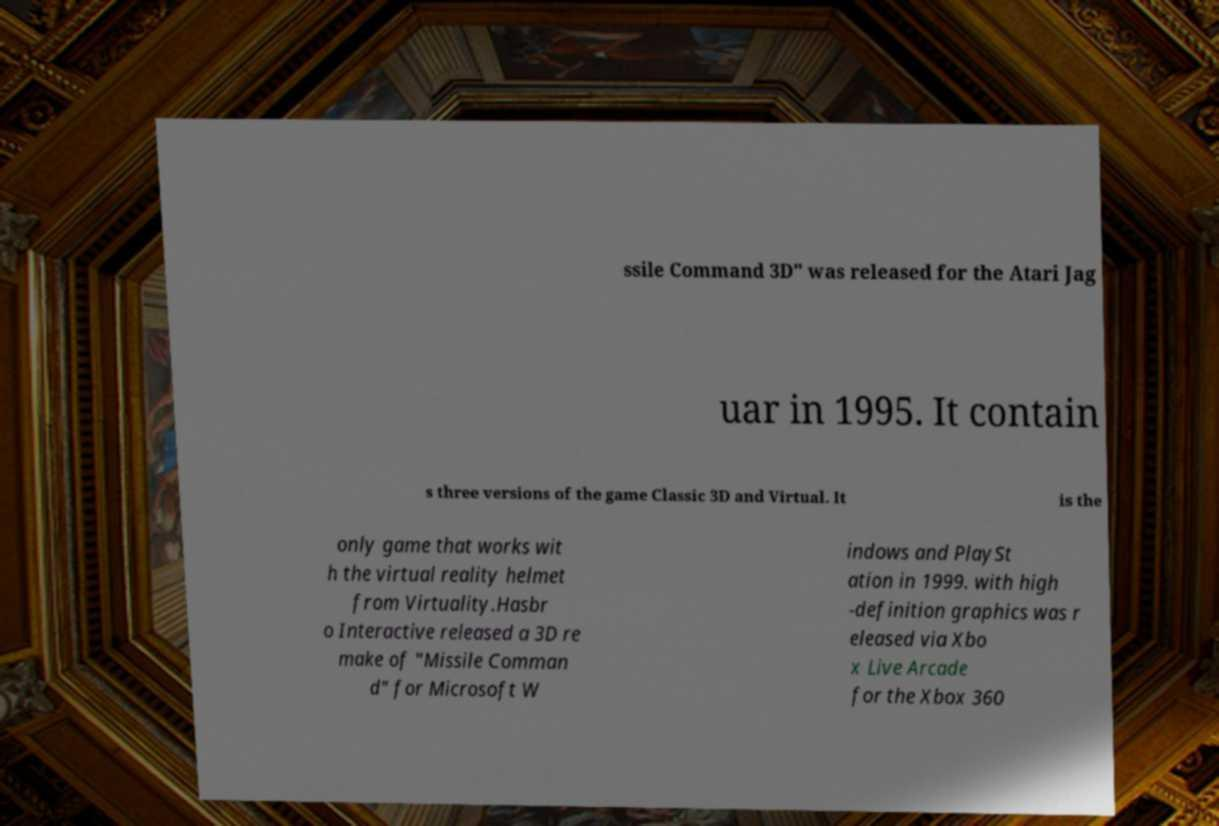Please read and relay the text visible in this image. What does it say? ssile Command 3D" was released for the Atari Jag uar in 1995. It contain s three versions of the game Classic 3D and Virtual. It is the only game that works wit h the virtual reality helmet from Virtuality.Hasbr o Interactive released a 3D re make of "Missile Comman d" for Microsoft W indows and PlaySt ation in 1999. with high -definition graphics was r eleased via Xbo x Live Arcade for the Xbox 360 